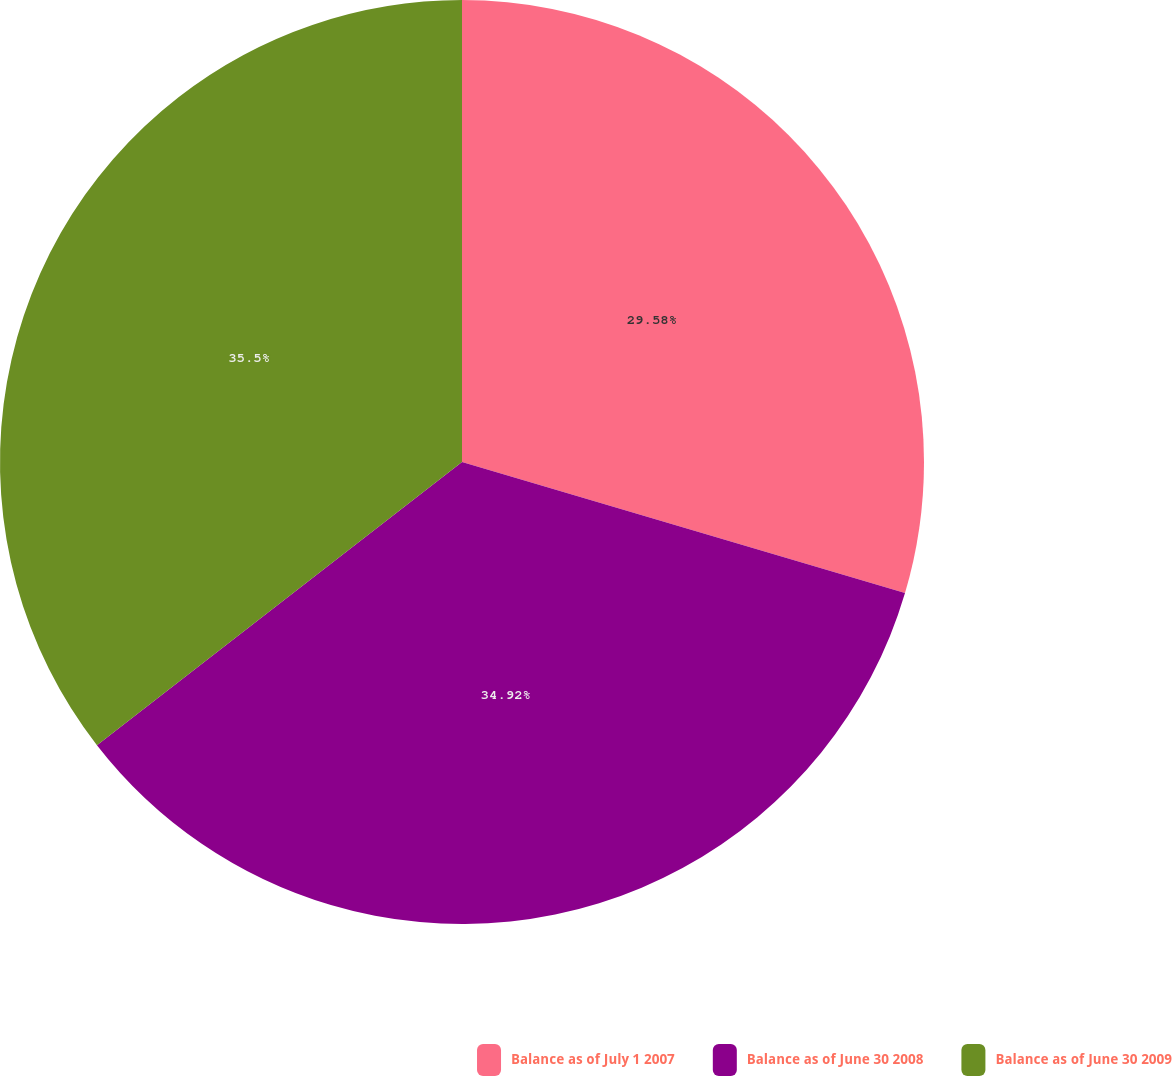Convert chart to OTSL. <chart><loc_0><loc_0><loc_500><loc_500><pie_chart><fcel>Balance as of July 1 2007<fcel>Balance as of June 30 2008<fcel>Balance as of June 30 2009<nl><fcel>29.58%<fcel>34.92%<fcel>35.5%<nl></chart> 